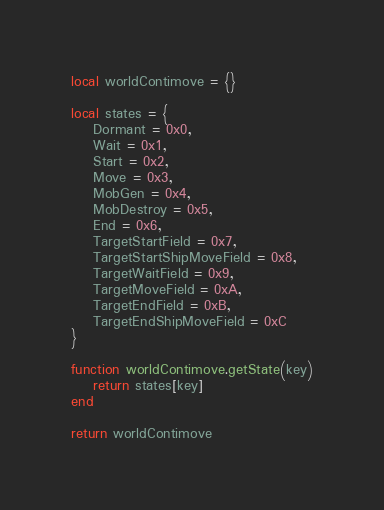Convert code to text. <code><loc_0><loc_0><loc_500><loc_500><_Lua_>local worldContimove = {}

local states = {
    Dormant = 0x0,
    Wait = 0x1,
    Start = 0x2,
    Move = 0x3,
    MobGen = 0x4,
    MobDestroy = 0x5,
    End = 0x6,
    TargetStartField = 0x7,
    TargetStartShipMoveField = 0x8,
    TargetWaitField = 0x9,
    TargetMoveField = 0xA,
    TargetEndField = 0xB,
    TargetEndShipMoveField = 0xC
}

function worldContimove.getState(key)
    return states[key]
end

return worldContimove</code> 